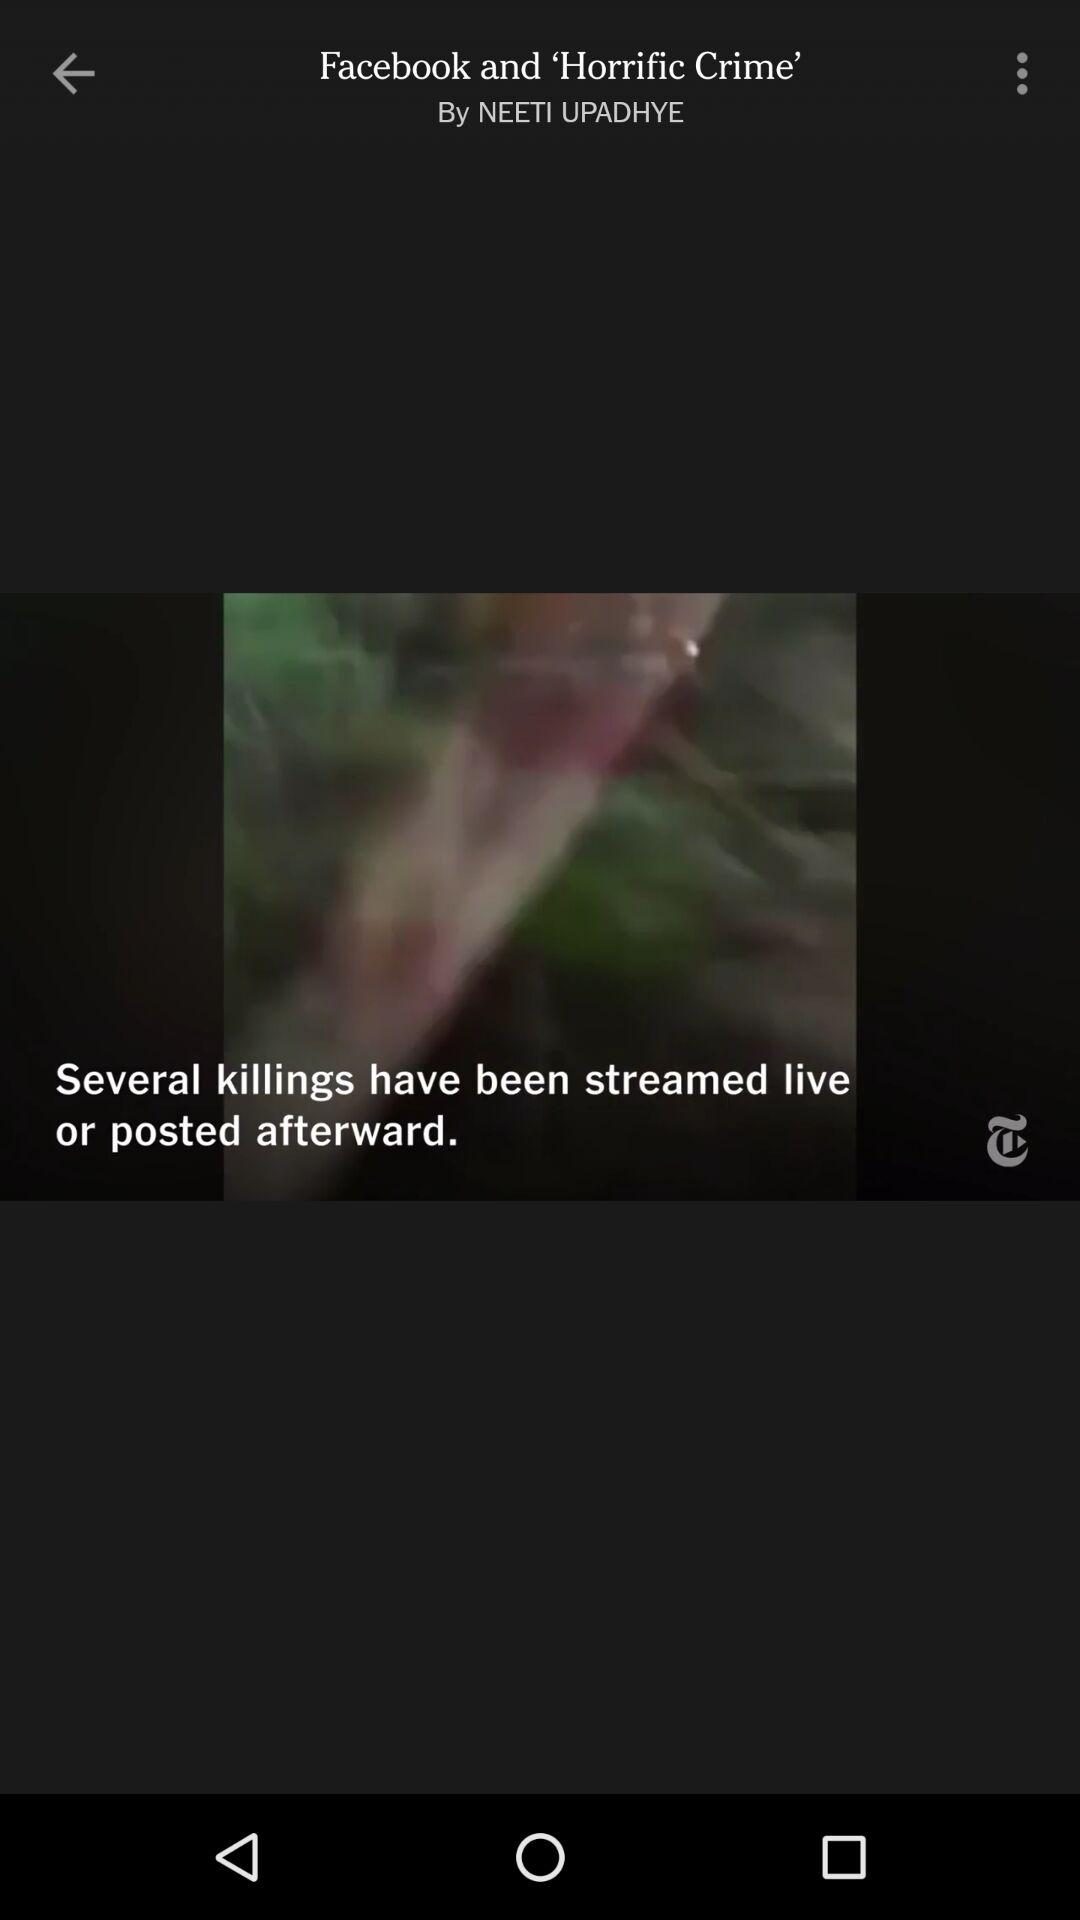Who is the author? The author is Neeti Upadhye. 